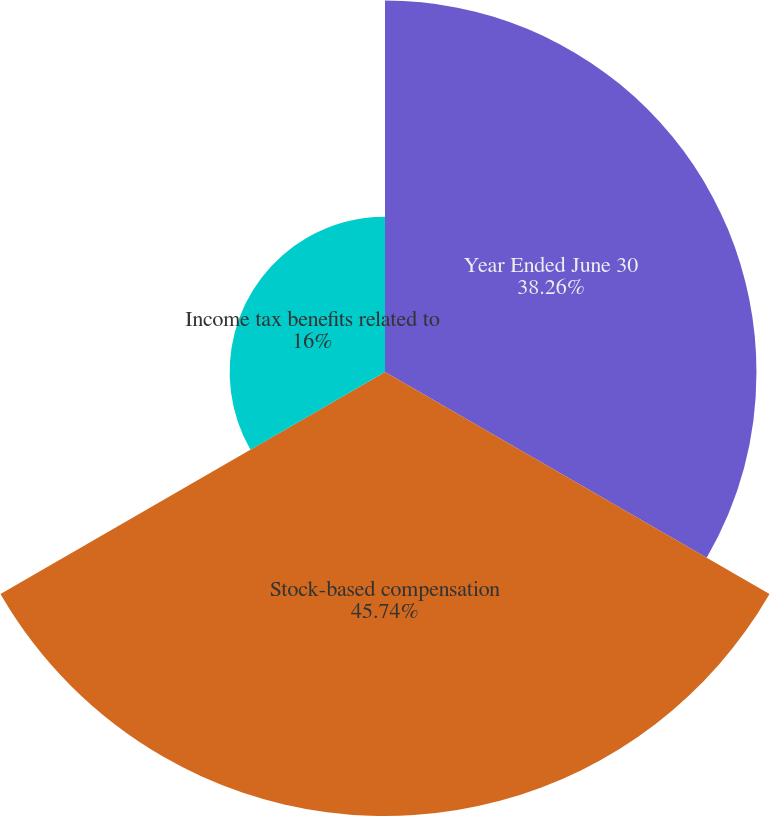Convert chart. <chart><loc_0><loc_0><loc_500><loc_500><pie_chart><fcel>Year Ended June 30<fcel>Stock-based compensation<fcel>Income tax benefits related to<nl><fcel>38.26%<fcel>45.73%<fcel>16.0%<nl></chart> 